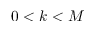Convert formula to latex. <formula><loc_0><loc_0><loc_500><loc_500>0 < k < M</formula> 